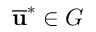Convert formula to latex. <formula><loc_0><loc_0><loc_500><loc_500>\overline { u } ^ { * } \in G</formula> 